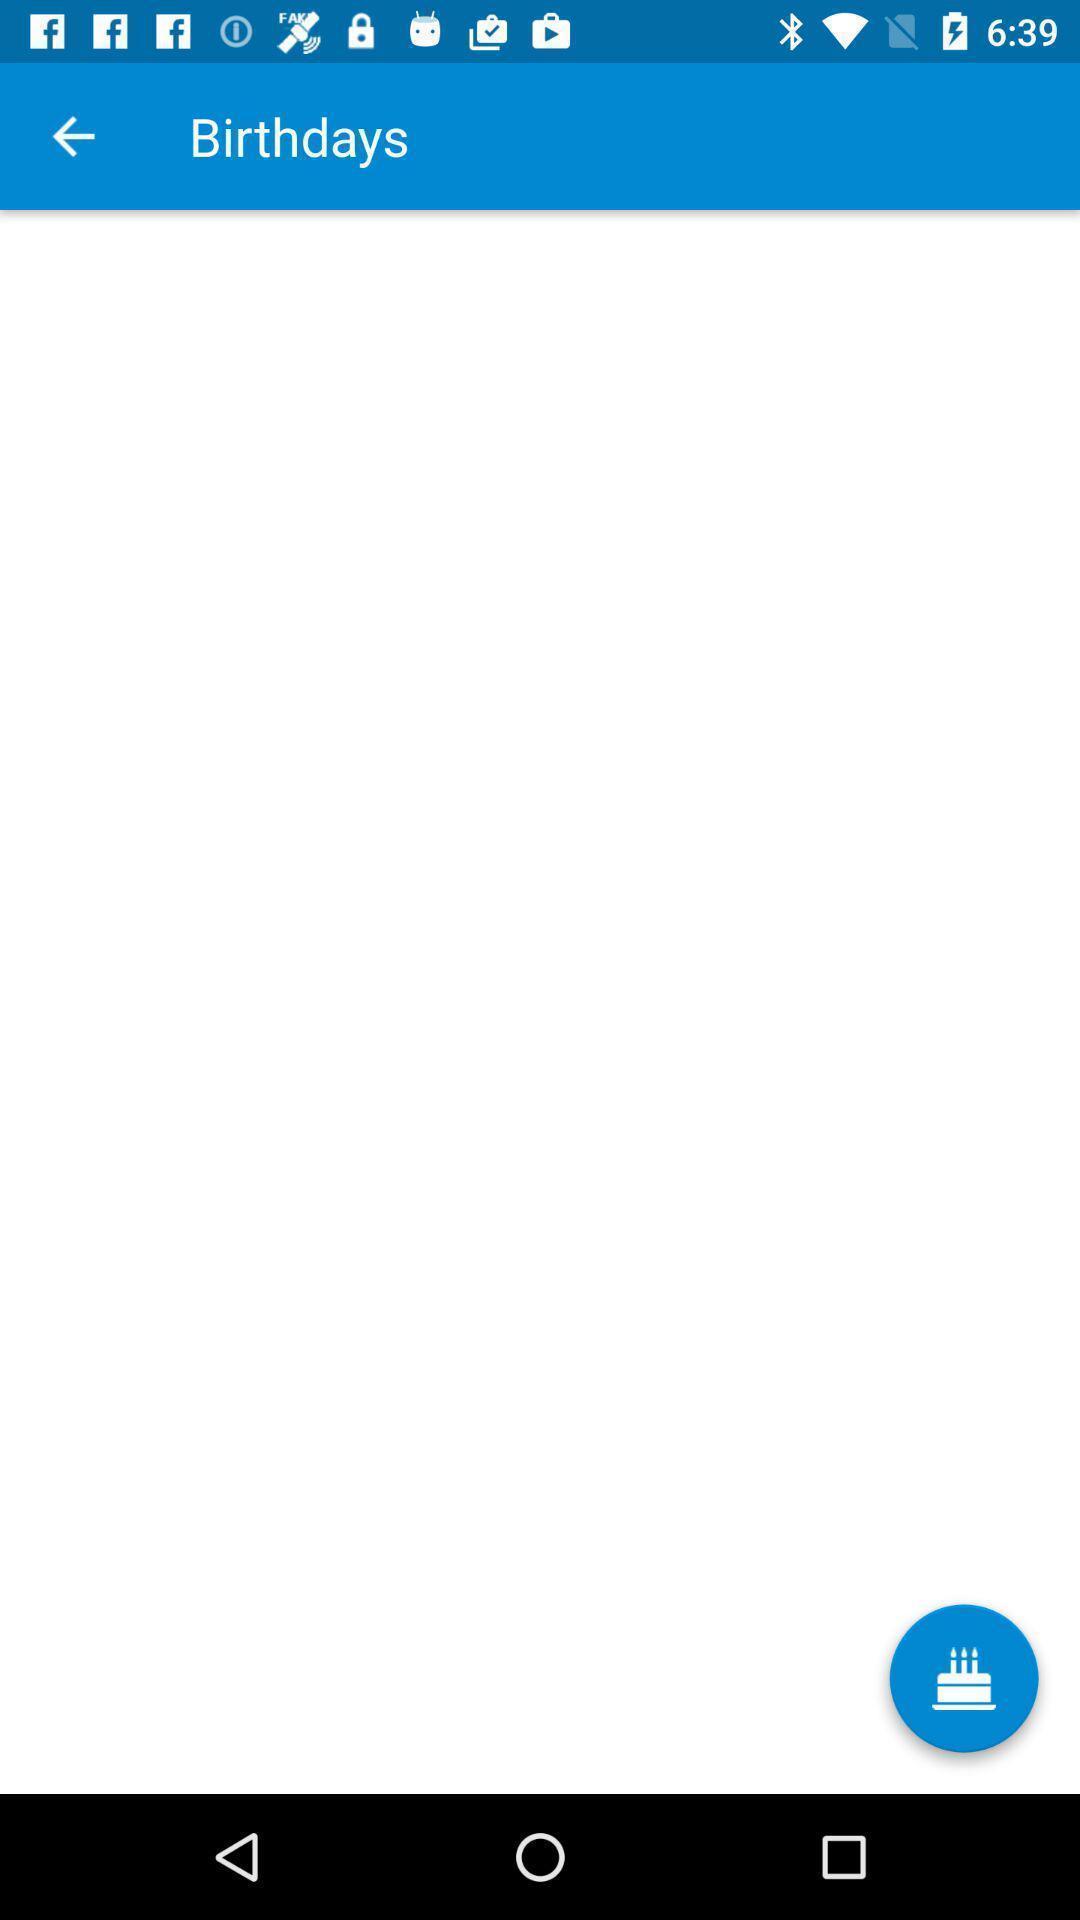Provide a detailed account of this screenshot. Window displaying a birthday page. 